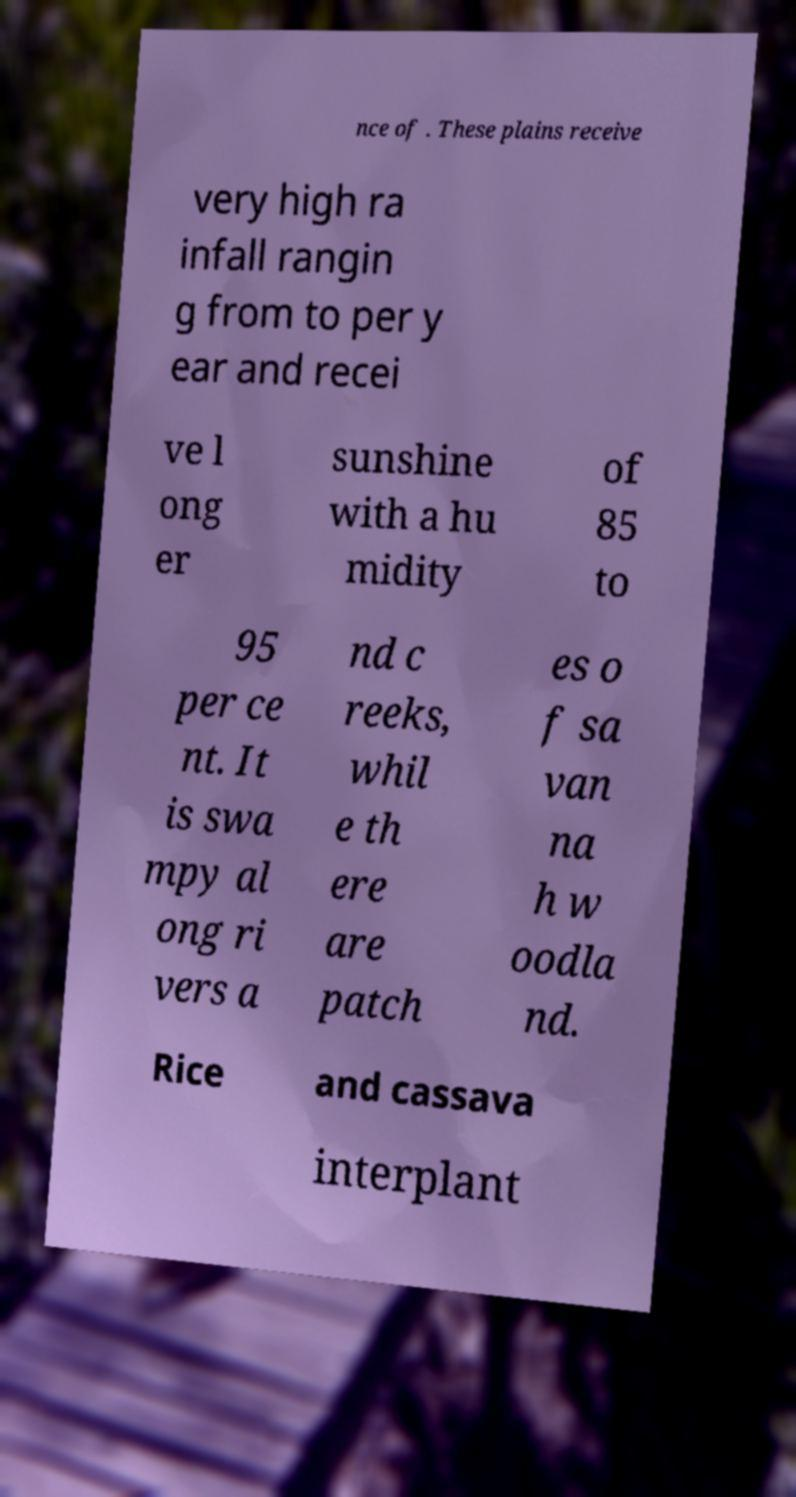Please read and relay the text visible in this image. What does it say? nce of . These plains receive very high ra infall rangin g from to per y ear and recei ve l ong er sunshine with a hu midity of 85 to 95 per ce nt. It is swa mpy al ong ri vers a nd c reeks, whil e th ere are patch es o f sa van na h w oodla nd. Rice and cassava interplant 